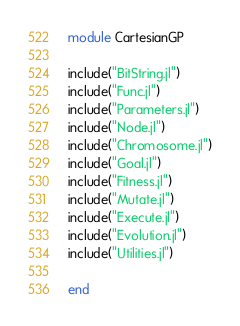Convert code to text. <code><loc_0><loc_0><loc_500><loc_500><_Julia_>module CartesianGP

include("BitString.jl")
include("Func.jl")
include("Parameters.jl")
include("Node.jl")
include("Chromosome.jl")
include("Goal.jl")
include("Fitness.jl")
include("Mutate.jl")
include("Execute.jl")
include("Evolution.jl")
include("Utilities.jl")

end
</code> 